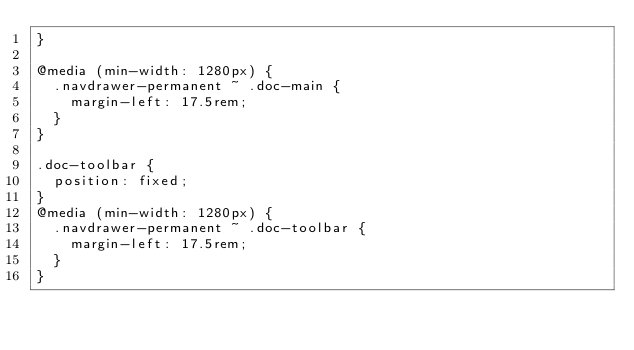Convert code to text. <code><loc_0><loc_0><loc_500><loc_500><_CSS_>}

@media (min-width: 1280px) {
  .navdrawer-permanent ~ .doc-main {
    margin-left: 17.5rem;
  }
}

.doc-toolbar {
  position: fixed;
}
@media (min-width: 1280px) {
  .navdrawer-permanent ~ .doc-toolbar {
    margin-left: 17.5rem;
  }
}</code> 